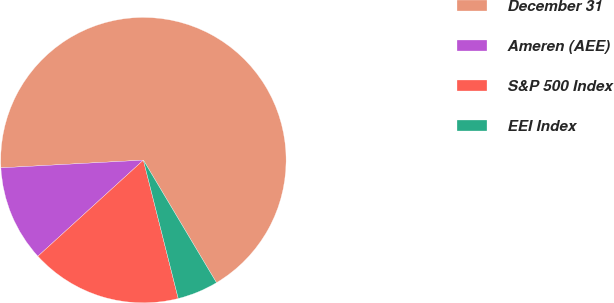<chart> <loc_0><loc_0><loc_500><loc_500><pie_chart><fcel>December 31<fcel>Ameren (AEE)<fcel>S&P 500 Index<fcel>EEI Index<nl><fcel>67.31%<fcel>10.9%<fcel>17.17%<fcel>4.63%<nl></chart> 